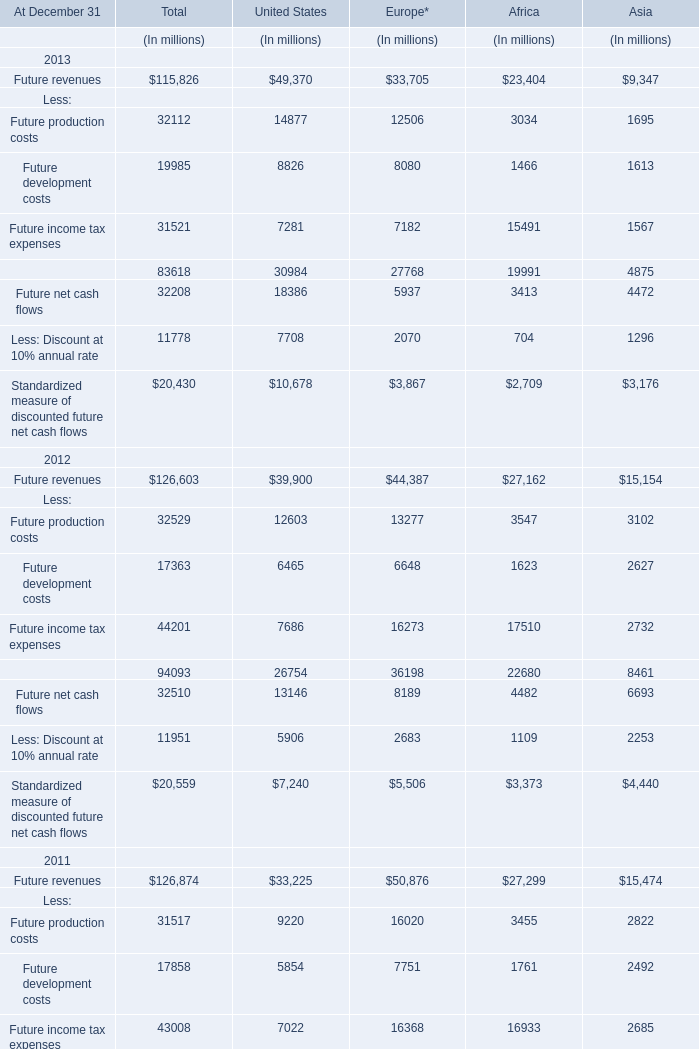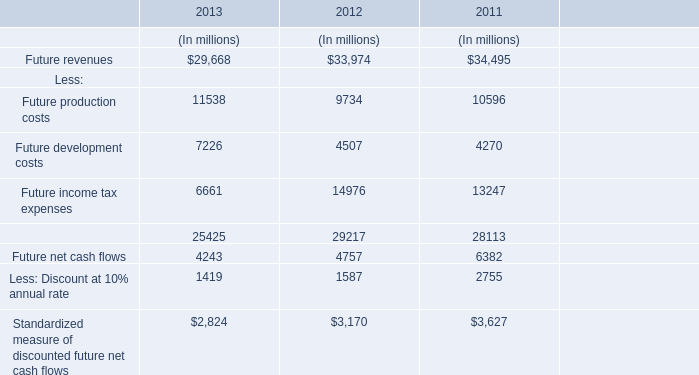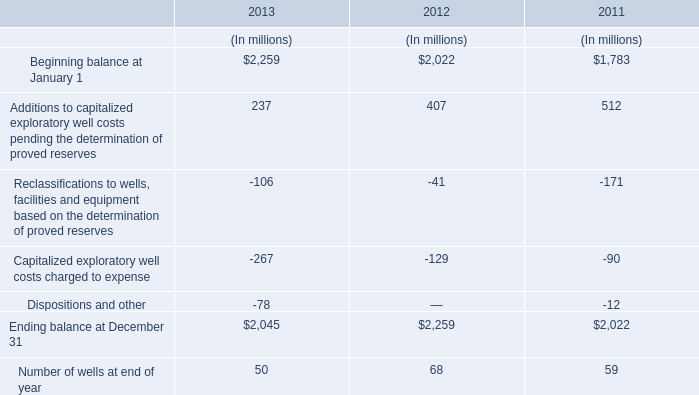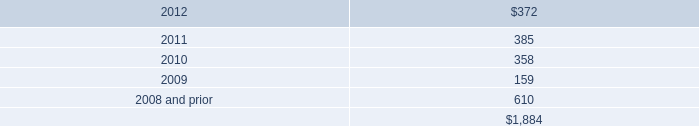In the year with largest amount of Future income tax expenses, what's the sum of costs? (in million) 
Computations: ((9734 + 4507) + 14976)
Answer: 29217.0. 